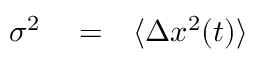<formula> <loc_0><loc_0><loc_500><loc_500>\begin{array} { r l r } { \sigma ^ { 2 } } & = } & { \langle \Delta x ^ { 2 } ( t ) \rangle } \end{array}</formula> 